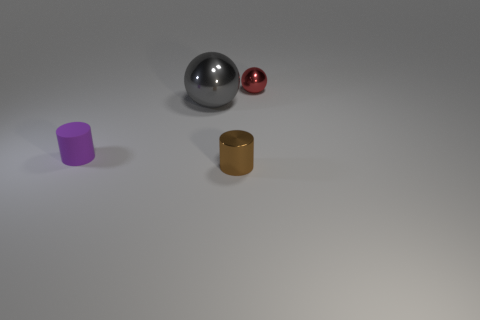What number of other things are the same shape as the tiny matte thing?
Offer a terse response. 1. What is the color of the small metallic thing that is to the left of the small metallic thing right of the small object that is in front of the matte cylinder?
Your answer should be very brief. Brown. Are the ball in front of the tiny red ball and the tiny thing behind the large gray sphere made of the same material?
Offer a terse response. Yes. What number of things are either balls that are behind the large gray ball or tiny red metal balls?
Offer a very short reply. 1. What number of objects are either large blue spheres or balls that are in front of the tiny red metal thing?
Give a very brief answer. 1. How many rubber things are the same size as the rubber cylinder?
Ensure brevity in your answer.  0. Is the number of small metal things that are in front of the brown shiny thing less than the number of metal things on the left side of the big ball?
Your answer should be very brief. No. How many shiny things are large blue cubes or big spheres?
Your answer should be very brief. 1. What shape is the small matte object?
Your answer should be very brief. Cylinder. There is a purple cylinder that is the same size as the brown cylinder; what is it made of?
Offer a terse response. Rubber. 